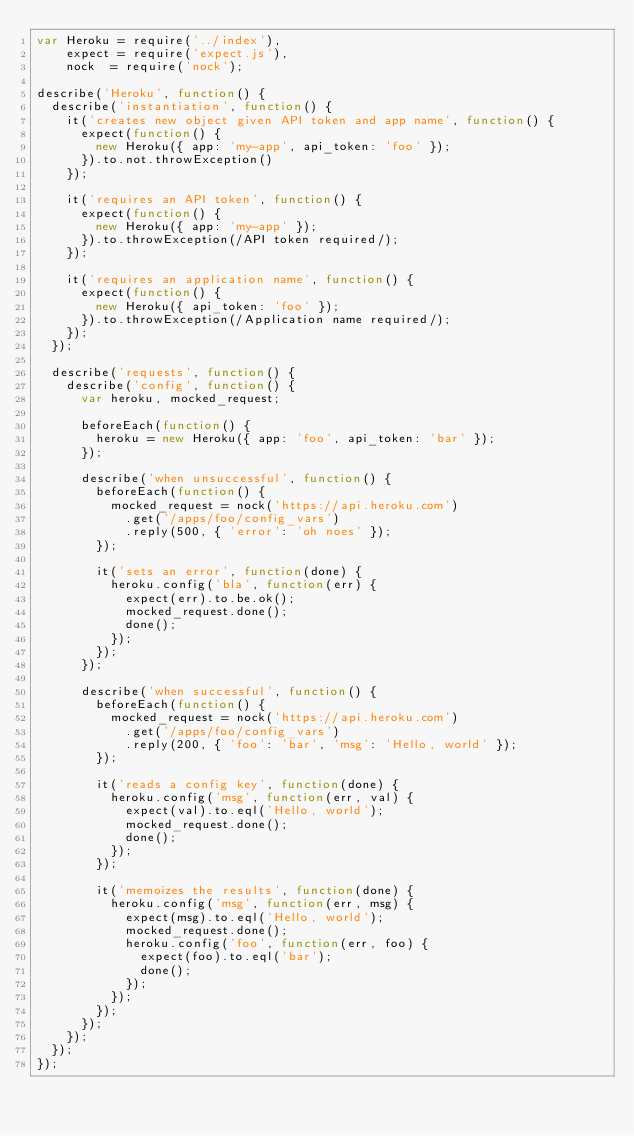<code> <loc_0><loc_0><loc_500><loc_500><_JavaScript_>var Heroku = require('../index'),
    expect = require('expect.js'),
    nock  = require('nock');

describe('Heroku', function() {
  describe('instantiation', function() {
    it('creates new object given API token and app name', function() {
      expect(function() {
        new Heroku({ app: 'my-app', api_token: 'foo' });
      }).to.not.throwException()
    });

    it('requires an API token', function() {
      expect(function() {
        new Heroku({ app: 'my-app' });
      }).to.throwException(/API token required/);
    });

    it('requires an application name', function() {
      expect(function() {
        new Heroku({ api_token: 'foo' });
      }).to.throwException(/Application name required/);
    });
  });

  describe('requests', function() {
    describe('config', function() {
      var heroku, mocked_request;

      beforeEach(function() {
        heroku = new Heroku({ app: 'foo', api_token: 'bar' });
      });

      describe('when unsuccessful', function() {
        beforeEach(function() {
          mocked_request = nock('https://api.heroku.com')
            .get('/apps/foo/config_vars')
            .reply(500, { 'error': 'oh noes' });
        });

        it('sets an error', function(done) {
          heroku.config('bla', function(err) {
            expect(err).to.be.ok();
            mocked_request.done();
            done();
          });
        });
      });

      describe('when successful', function() {
        beforeEach(function() {
          mocked_request = nock('https://api.heroku.com')
            .get('/apps/foo/config_vars')
            .reply(200, { 'foo': 'bar', 'msg': 'Hello, world' });
        });

        it('reads a config key', function(done) {
          heroku.config('msg', function(err, val) {
            expect(val).to.eql('Hello, world');
            mocked_request.done();
            done();
          });
        });

        it('memoizes the results', function(done) {
          heroku.config('msg', function(err, msg) {
            expect(msg).to.eql('Hello, world');
            mocked_request.done();
            heroku.config('foo', function(err, foo) {
              expect(foo).to.eql('bar');
              done();
            });
          });
        });
      });
    });
  });
});
</code> 